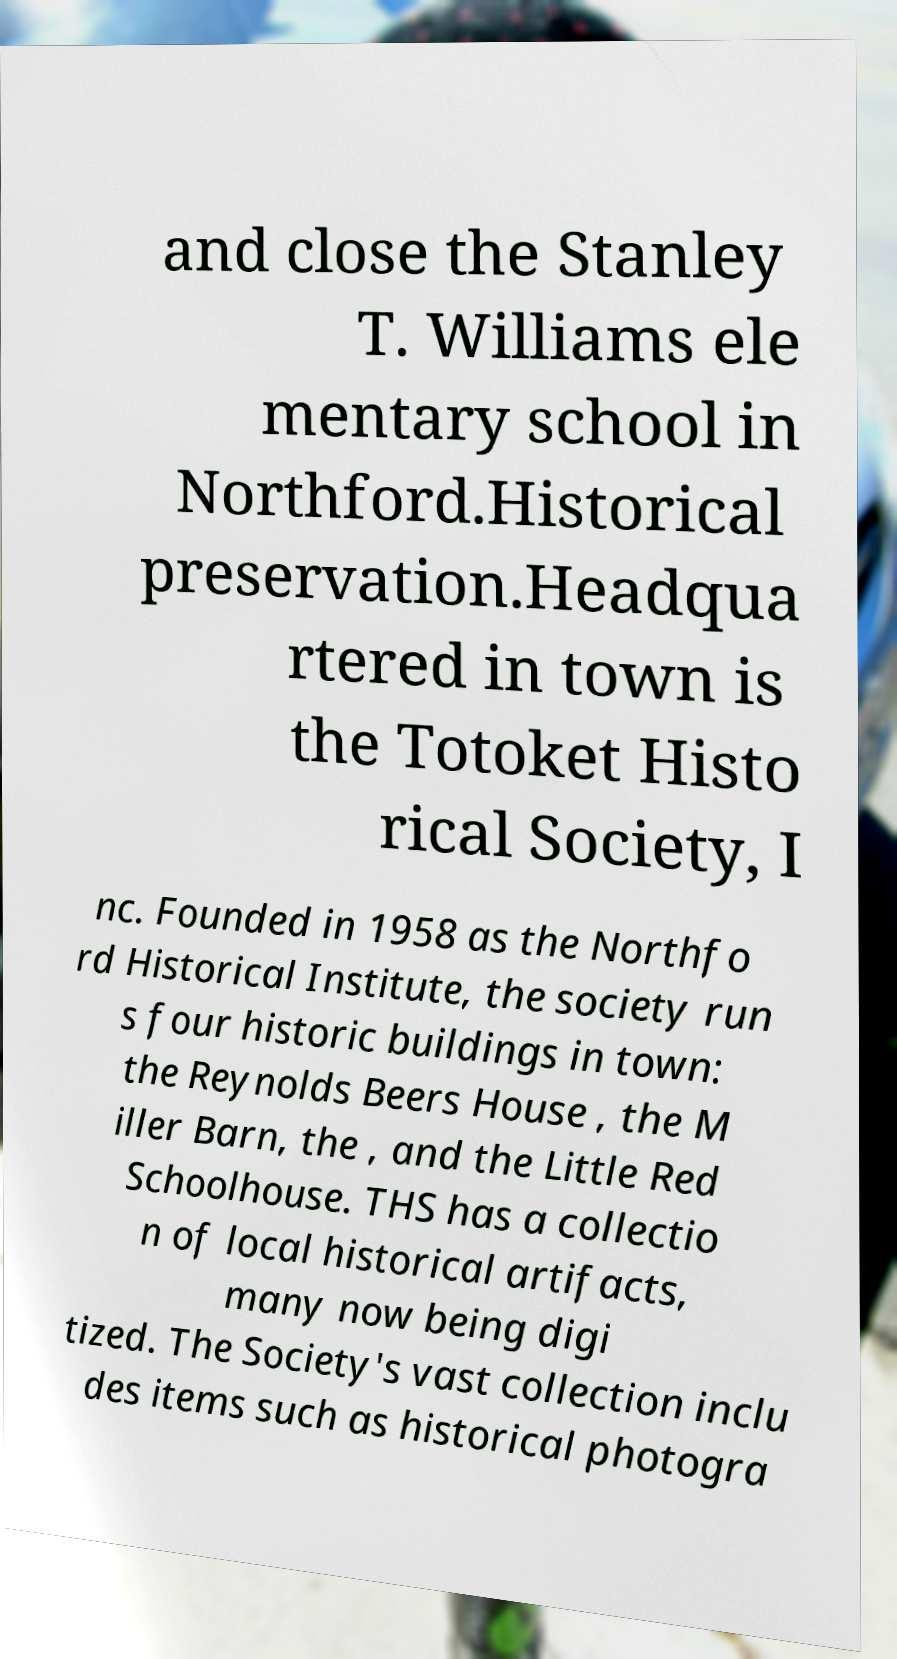I need the written content from this picture converted into text. Can you do that? and close the Stanley T. Williams ele mentary school in Northford.Historical preservation.Headqua rtered in town is the Totoket Histo rical Society, I nc. Founded in 1958 as the Northfo rd Historical Institute, the society run s four historic buildings in town: the Reynolds Beers House , the M iller Barn, the , and the Little Red Schoolhouse. THS has a collectio n of local historical artifacts, many now being digi tized. The Society's vast collection inclu des items such as historical photogra 